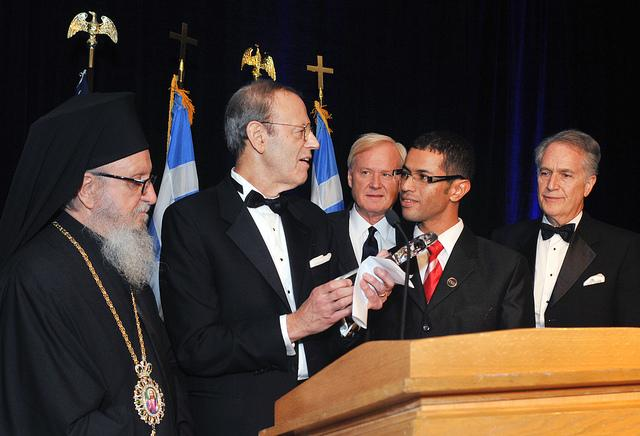The man on the left is probably a member of what type of group? Please explain your reasoning. clergy. With his unique clothing and large religious necklace, the man is obviously a member of some sect of religion. such representatives of organized religions often offer prayers during public events. 